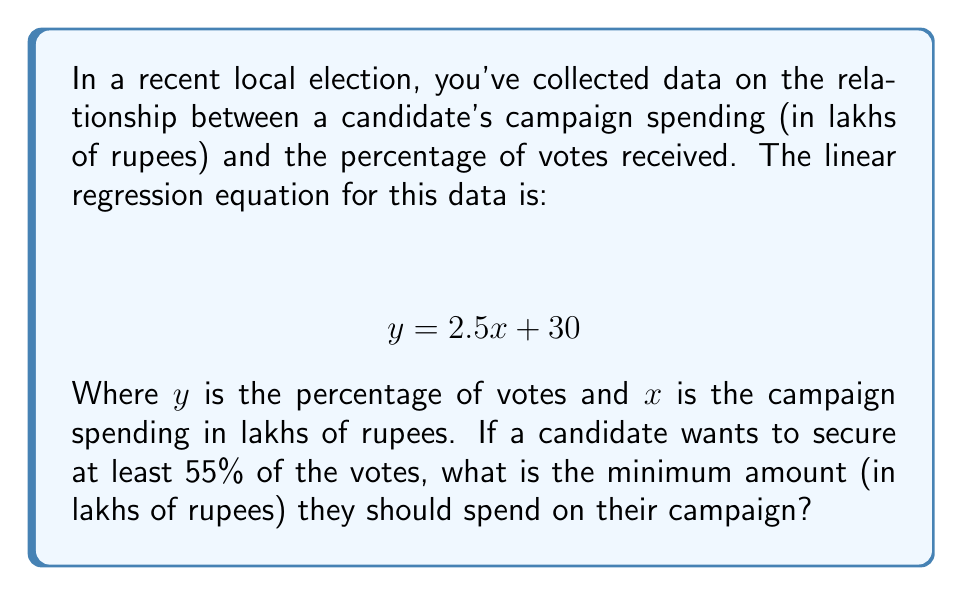Provide a solution to this math problem. To solve this problem, we'll follow these steps:

1) We're given the linear regression equation:
   $$ y = 2.5x + 30 $$

2) We want to find $x$ when $y$ is at least 55%. So, we set up the inequality:
   $$ 55 \leq 2.5x + 30 $$

3) Subtract 30 from both sides:
   $$ 25 \leq 2.5x $$

4) Divide both sides by 2.5:
   $$ 10 \leq x $$

5) Therefore, the candidate needs to spend at least 10 lakhs of rupees.

6) To verify:
   If $x = 10$, then $y = 2.5(10) + 30 = 55$

So, spending 10 lakhs will result in exactly 55% of the votes. Any amount less than 10 lakhs will result in less than 55% of the votes.
Answer: 10 lakhs 